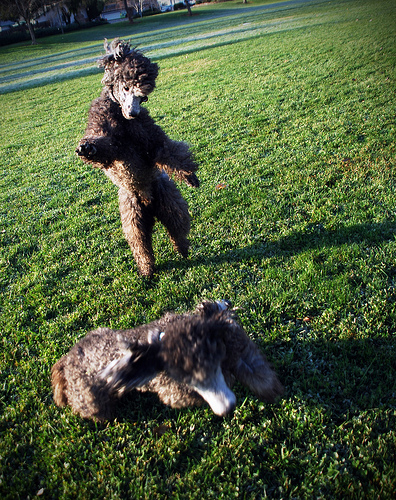<image>
Is the dog on the grace? Yes. Looking at the image, I can see the dog is positioned on top of the grace, with the grace providing support. 